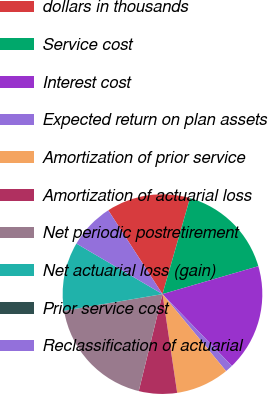<chart> <loc_0><loc_0><loc_500><loc_500><pie_chart><fcel>dollars in thousands<fcel>Service cost<fcel>Interest cost<fcel>Expected return on plan assets<fcel>Amortization of prior service<fcel>Amortization of actuarial loss<fcel>Net periodic postretirement<fcel>Net actuarial loss (gain)<fcel>Prior service cost<fcel>Reclassification of actuarial<nl><fcel>13.58%<fcel>16.05%<fcel>17.28%<fcel>1.24%<fcel>8.64%<fcel>6.17%<fcel>18.52%<fcel>11.11%<fcel>0.0%<fcel>7.41%<nl></chart> 